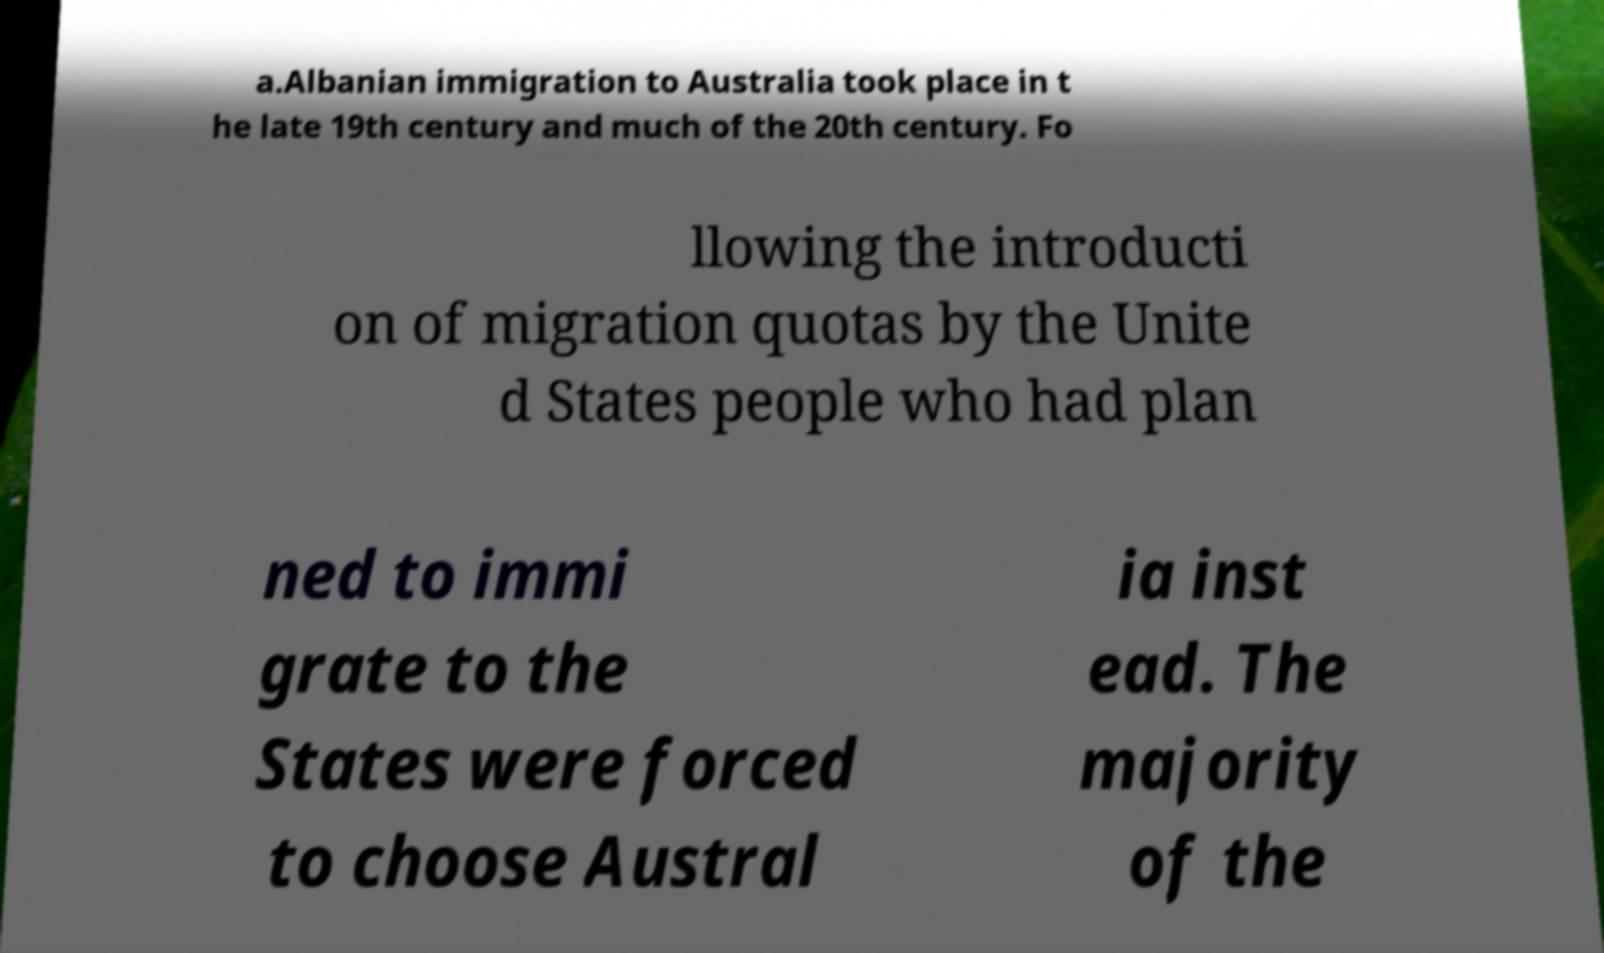Can you accurately transcribe the text from the provided image for me? a.Albanian immigration to Australia took place in t he late 19th century and much of the 20th century. Fo llowing the introducti on of migration quotas by the Unite d States people who had plan ned to immi grate to the States were forced to choose Austral ia inst ead. The majority of the 